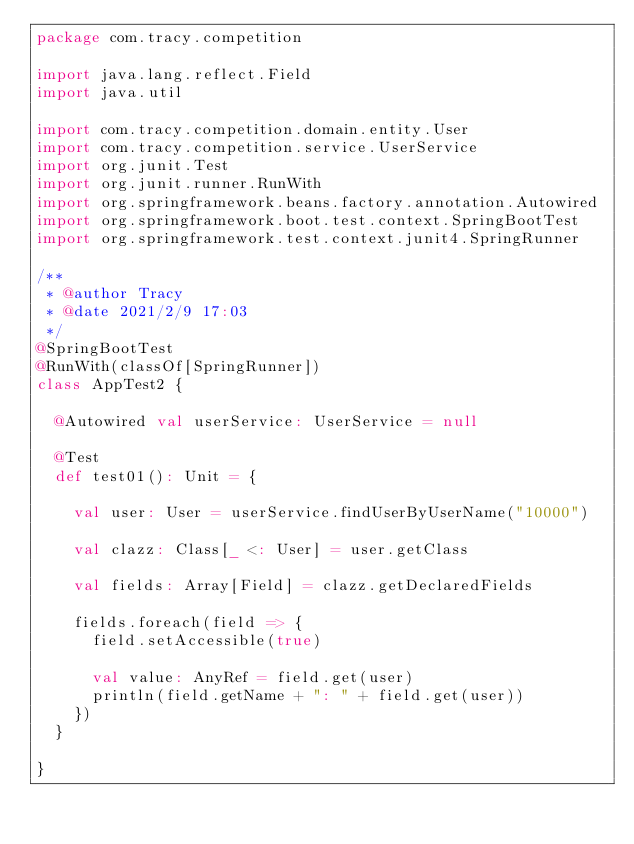Convert code to text. <code><loc_0><loc_0><loc_500><loc_500><_Scala_>package com.tracy.competition

import java.lang.reflect.Field
import java.util

import com.tracy.competition.domain.entity.User
import com.tracy.competition.service.UserService
import org.junit.Test
import org.junit.runner.RunWith
import org.springframework.beans.factory.annotation.Autowired
import org.springframework.boot.test.context.SpringBootTest
import org.springframework.test.context.junit4.SpringRunner

/**
 * @author Tracy
 * @date 2021/2/9 17:03
 */
@SpringBootTest
@RunWith(classOf[SpringRunner])
class AppTest2 {

  @Autowired val userService: UserService = null

  @Test
  def test01(): Unit = {

    val user: User = userService.findUserByUserName("10000")

    val clazz: Class[_ <: User] = user.getClass

    val fields: Array[Field] = clazz.getDeclaredFields

    fields.foreach(field => {
      field.setAccessible(true)

      val value: AnyRef = field.get(user)
      println(field.getName + ": " + field.get(user))
    })
  }

}
</code> 